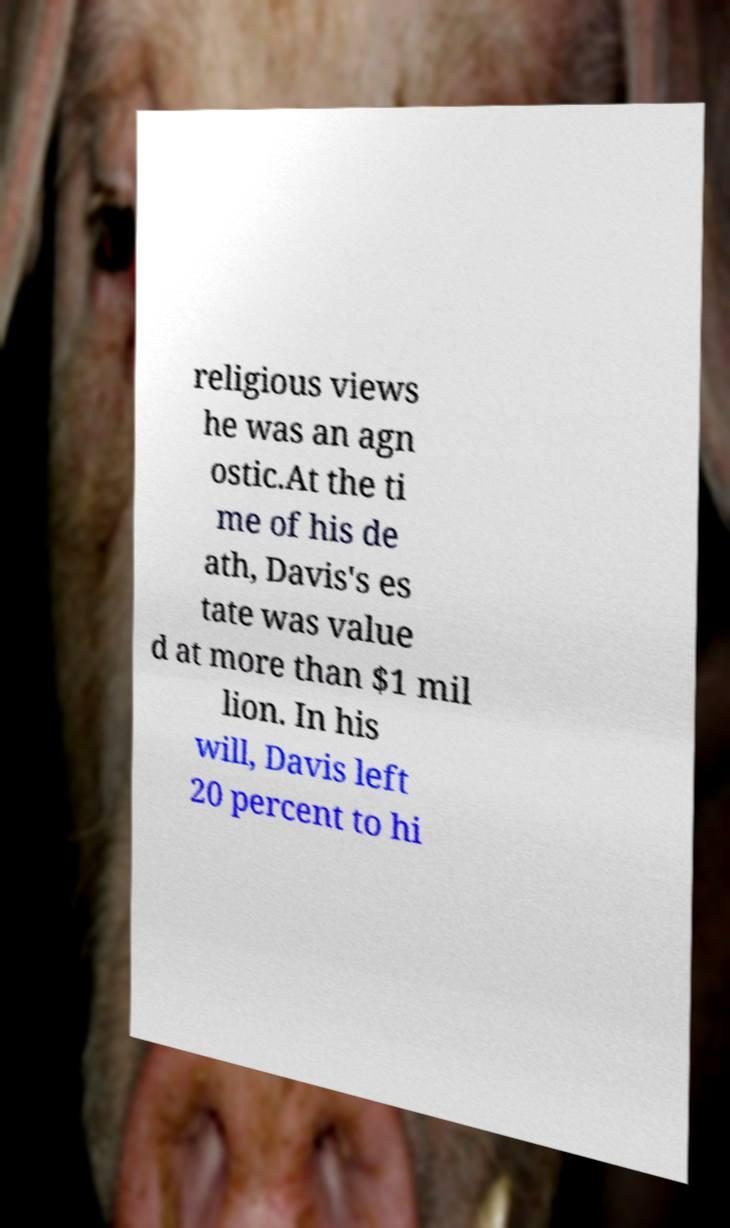For documentation purposes, I need the text within this image transcribed. Could you provide that? religious views he was an agn ostic.At the ti me of his de ath, Davis's es tate was value d at more than $1 mil lion. In his will, Davis left 20 percent to hi 